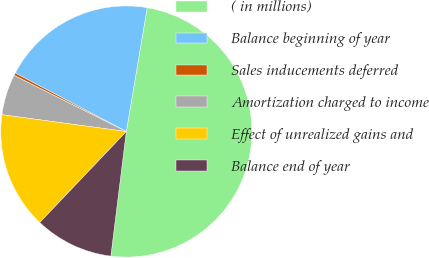Convert chart. <chart><loc_0><loc_0><loc_500><loc_500><pie_chart><fcel>( in millions)<fcel>Balance beginning of year<fcel>Sales inducements deferred<fcel>Amortization charged to income<fcel>Effect of unrealized gains and<fcel>Balance end of year<nl><fcel>49.31%<fcel>19.93%<fcel>0.34%<fcel>5.24%<fcel>15.03%<fcel>10.14%<nl></chart> 